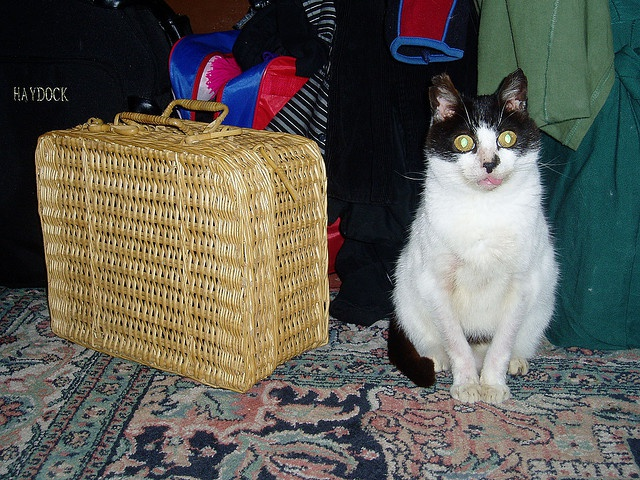Describe the objects in this image and their specific colors. I can see suitcase in black, tan, and olive tones, cat in black, lightgray, darkgray, and gray tones, and suitcase in black, gray, tan, and darkgray tones in this image. 